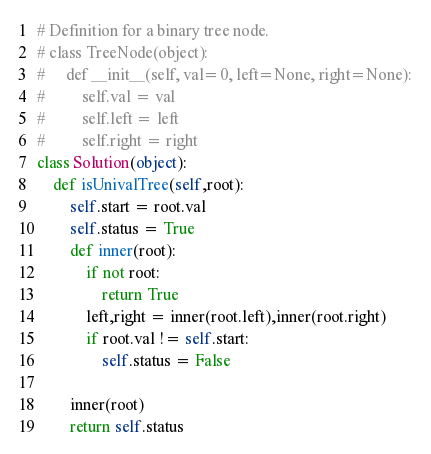Convert code to text. <code><loc_0><loc_0><loc_500><loc_500><_Python_># Definition for a binary tree node.
# class TreeNode(object):
#     def __init__(self, val=0, left=None, right=None):
#         self.val = val
#         self.left = left
#         self.right = right
class Solution(object):
    def isUnivalTree(self,root):
        self.start = root.val
        self.status = True
        def inner(root):
            if not root:
                return True
            left,right = inner(root.left),inner(root.right)
            if root.val != self.start:
                self.status = False

        inner(root)
        return self.status

</code> 